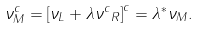Convert formula to latex. <formula><loc_0><loc_0><loc_500><loc_500>\nu _ { M } ^ { c } = \left [ \nu _ { L } + \lambda { \nu ^ { c } } _ { R } \right ] ^ { c } = \lambda ^ { \ast } \nu _ { M } .</formula> 